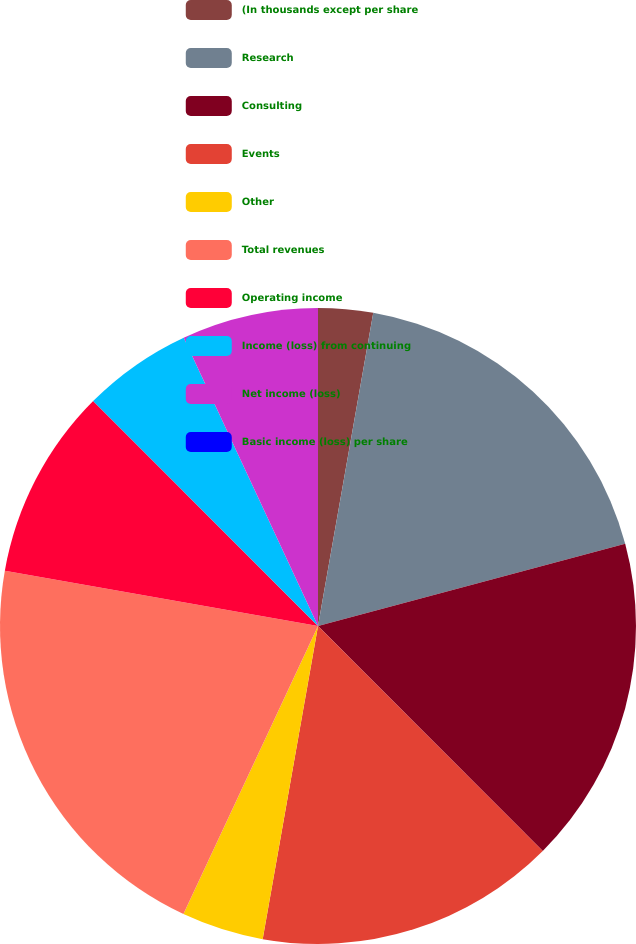Convert chart. <chart><loc_0><loc_0><loc_500><loc_500><pie_chart><fcel>(In thousands except per share<fcel>Research<fcel>Consulting<fcel>Events<fcel>Other<fcel>Total revenues<fcel>Operating income<fcel>Income (loss) from continuing<fcel>Net income (loss)<fcel>Basic income (loss) per share<nl><fcel>2.78%<fcel>18.06%<fcel>16.67%<fcel>15.28%<fcel>4.17%<fcel>20.83%<fcel>9.72%<fcel>5.56%<fcel>6.94%<fcel>0.0%<nl></chart> 